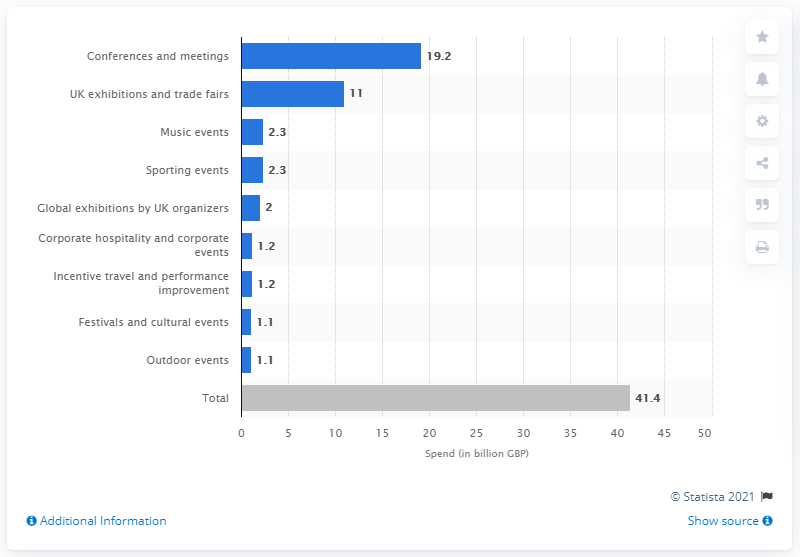What is the total expenditure represented in this chart? The total expenditure represented in this chart sums up to 41.4 billion GBP. 